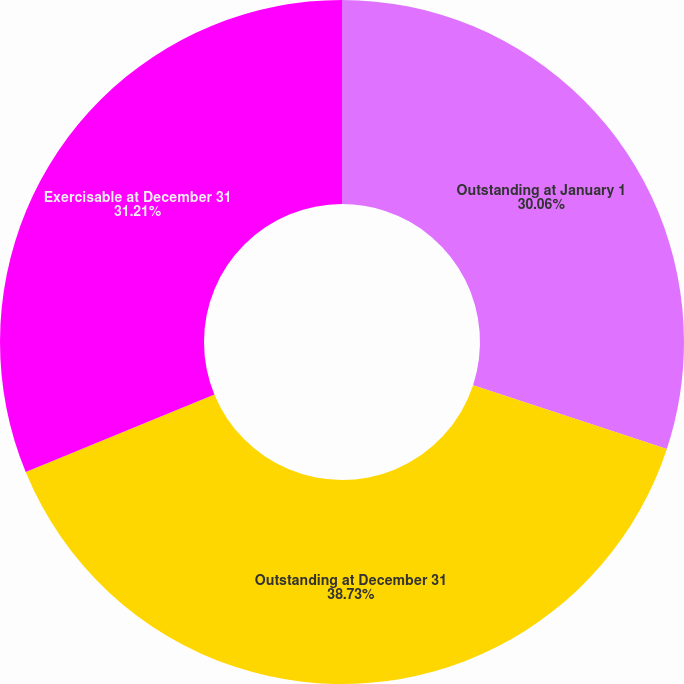Convert chart. <chart><loc_0><loc_0><loc_500><loc_500><pie_chart><fcel>Outstanding at January 1<fcel>Outstanding at December 31<fcel>Exercisable at December 31<nl><fcel>30.06%<fcel>38.73%<fcel>31.21%<nl></chart> 